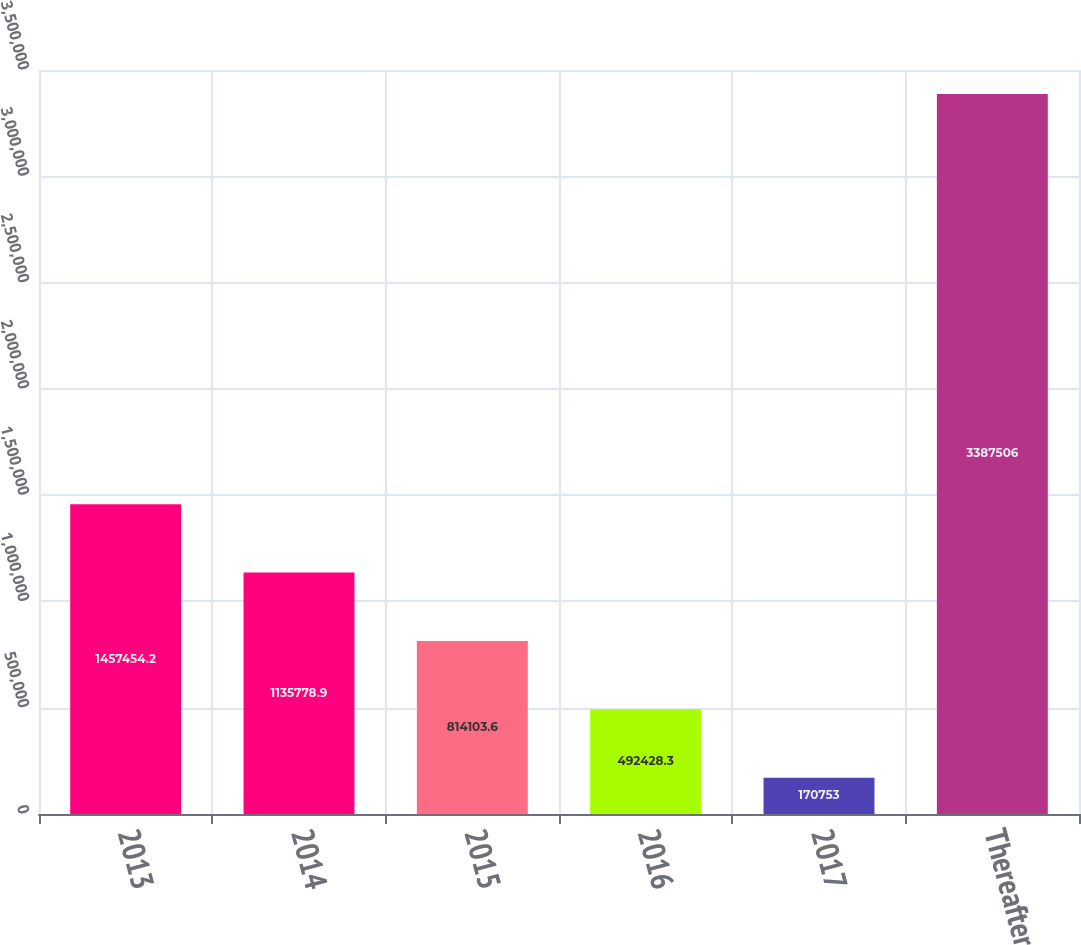<chart> <loc_0><loc_0><loc_500><loc_500><bar_chart><fcel>2013<fcel>2014<fcel>2015<fcel>2016<fcel>2017<fcel>Thereafter<nl><fcel>1.45745e+06<fcel>1.13578e+06<fcel>814104<fcel>492428<fcel>170753<fcel>3.38751e+06<nl></chart> 